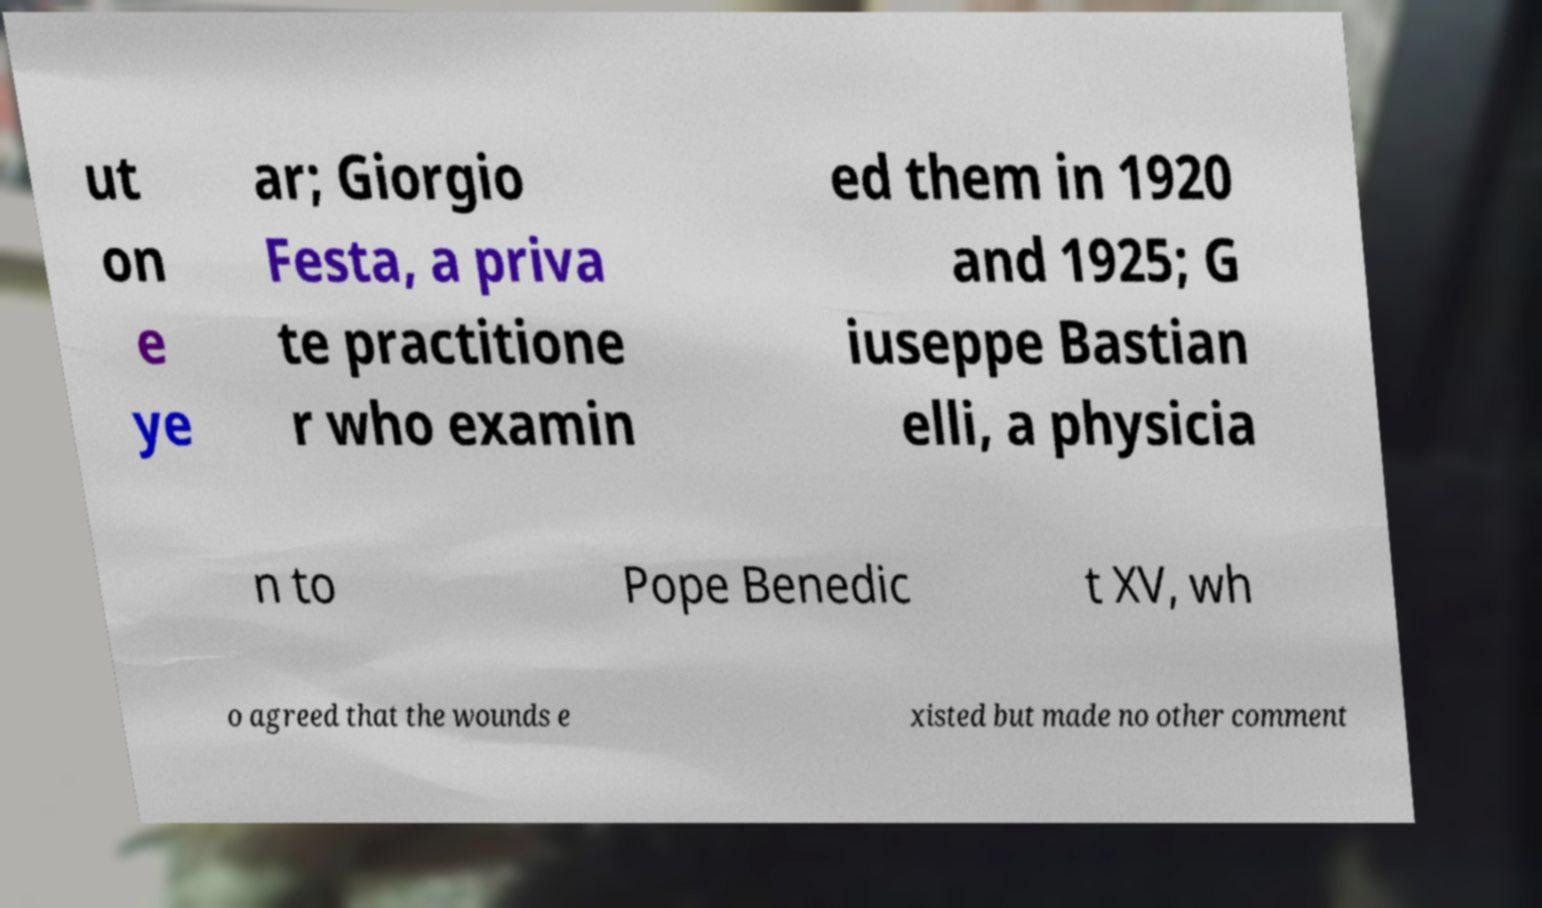Please identify and transcribe the text found in this image. ut on e ye ar; Giorgio Festa, a priva te practitione r who examin ed them in 1920 and 1925; G iuseppe Bastian elli, a physicia n to Pope Benedic t XV, wh o agreed that the wounds e xisted but made no other comment 